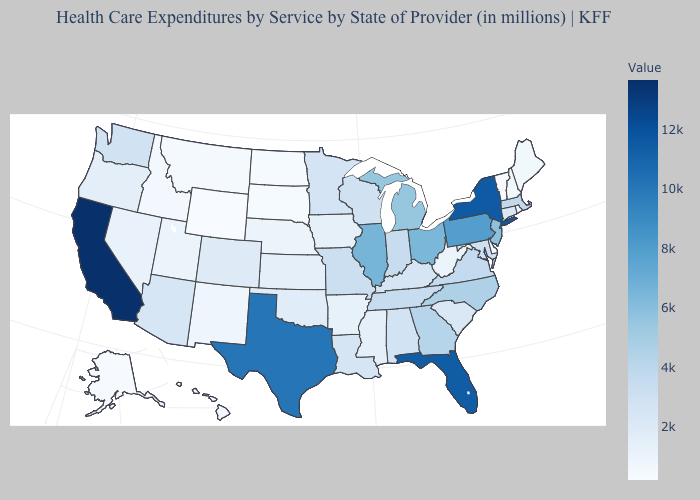Among the states that border Nebraska , which have the lowest value?
Write a very short answer. Wyoming. Is the legend a continuous bar?
Write a very short answer. Yes. Does Utah have a lower value than Maryland?
Short answer required. Yes. Which states hav the highest value in the Northeast?
Write a very short answer. New York. Does New York have the highest value in the Northeast?
Quick response, please. Yes. Among the states that border Vermont , which have the highest value?
Short answer required. New York. Which states hav the highest value in the West?
Give a very brief answer. California. 